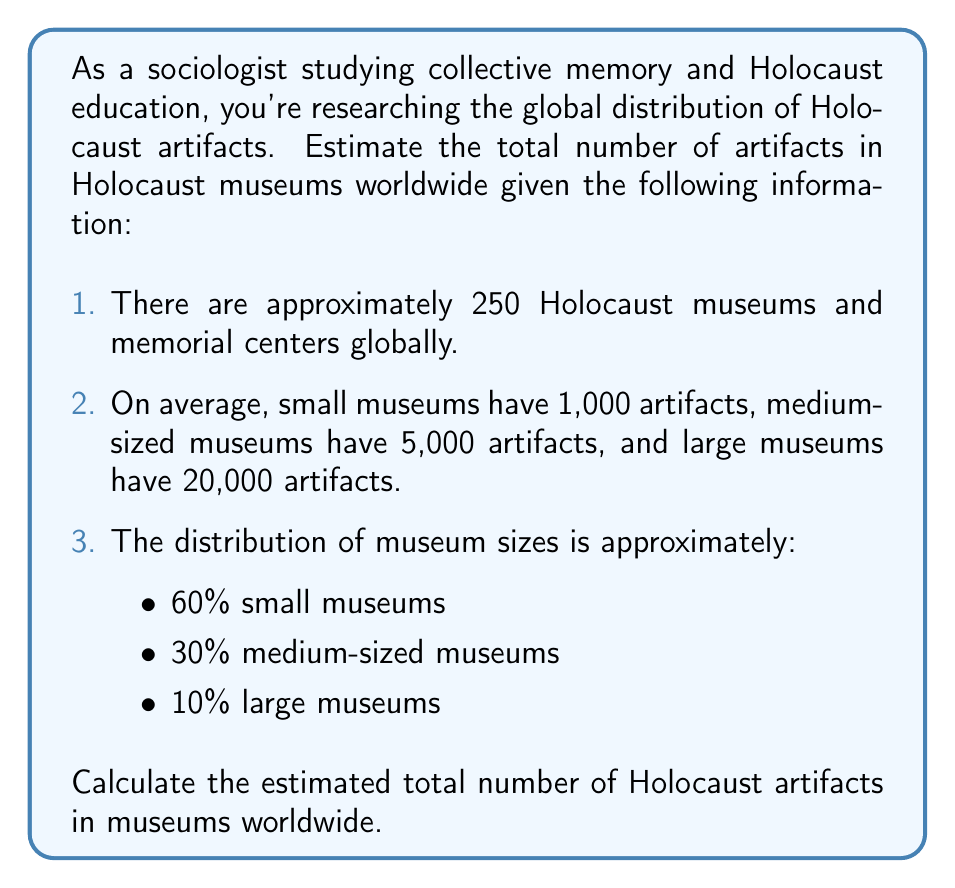Show me your answer to this math problem. To solve this problem, we'll use a weighted average approach:

1. Calculate the number of museums in each size category:
   - Small museums: $250 \times 0.60 = 150$
   - Medium museums: $250 \times 0.30 = 75$
   - Large museums: $250 \times 0.10 = 25$

2. Calculate the total number of artifacts for each museum size:
   - Small museums: $150 \times 1,000 = 150,000$
   - Medium museums: $75 \times 5,000 = 375,000$
   - Large museums: $25 \times 20,000 = 500,000$

3. Sum up the total artifacts:
   $$\text{Total artifacts} = 150,000 + 375,000 + 500,000 = 1,025,000$$

Therefore, the estimated total number of Holocaust artifacts in museums worldwide is 1,025,000.
Answer: The estimated total number of Holocaust artifacts in museums worldwide is 1,025,000. 